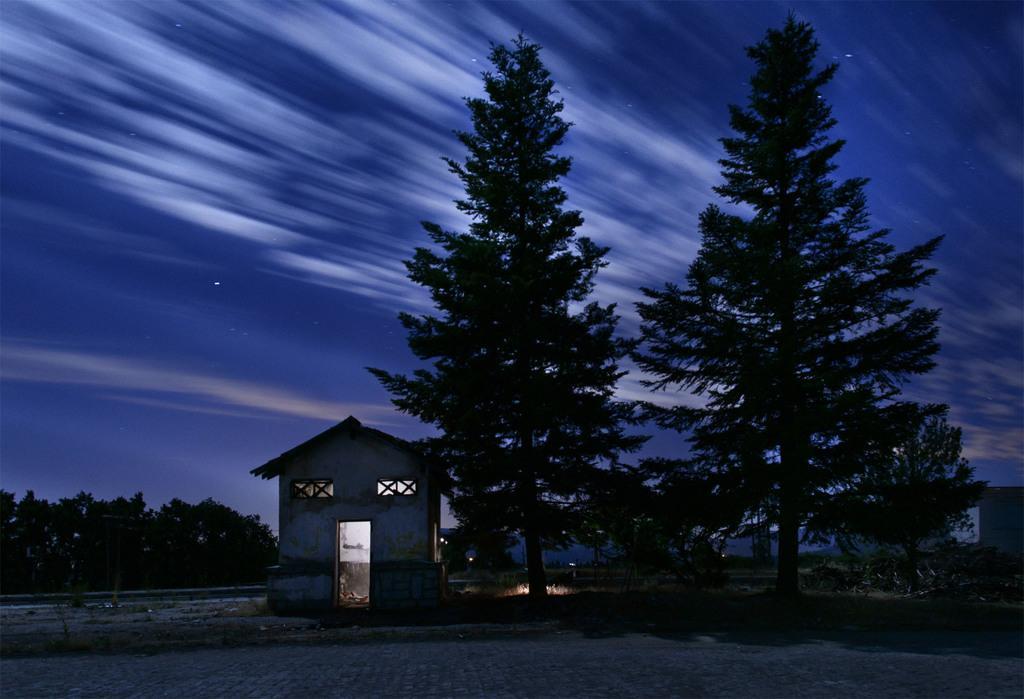Could you give a brief overview of what you see in this image? This is an image clicked in the dark. In the middle of the image there are many trees and houses. At the top of the image I can see the sky. 